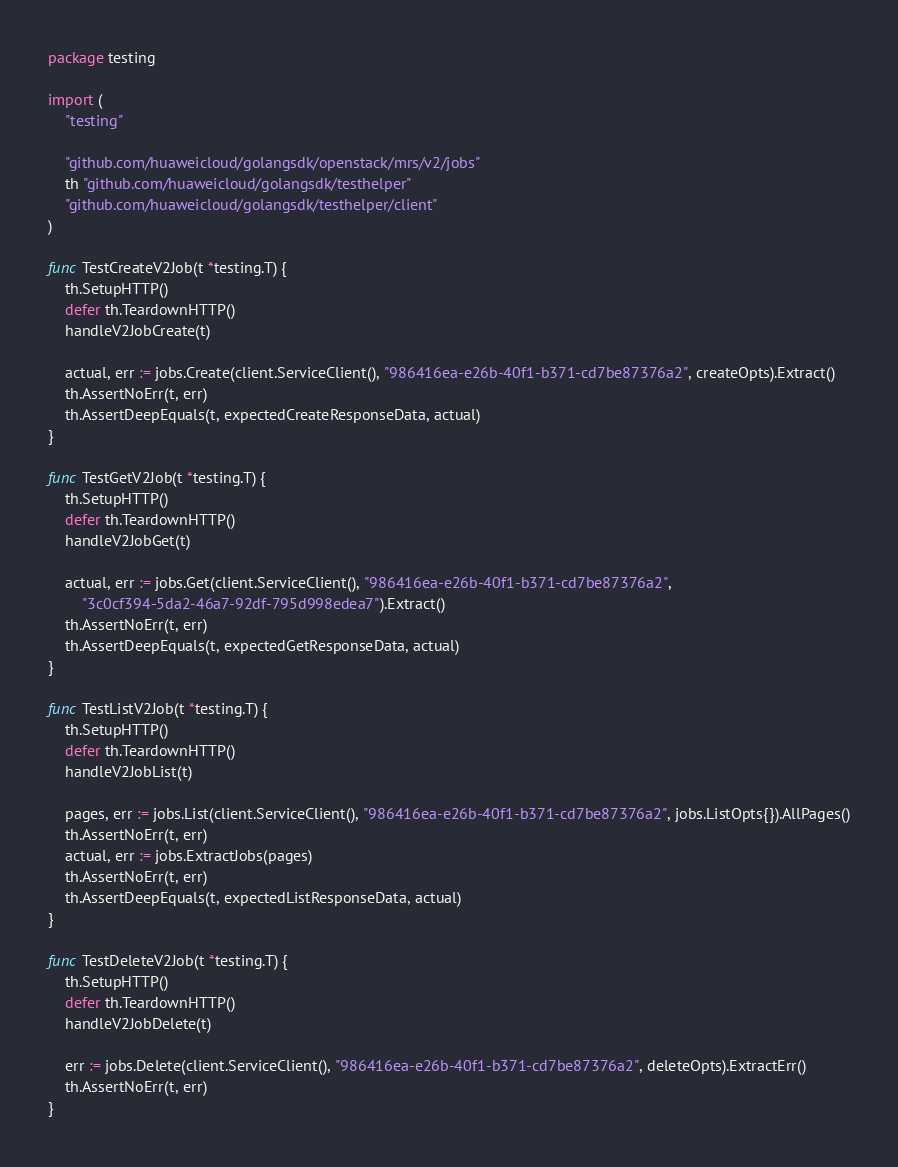Convert code to text. <code><loc_0><loc_0><loc_500><loc_500><_Go_>package testing

import (
	"testing"

	"github.com/huaweicloud/golangsdk/openstack/mrs/v2/jobs"
	th "github.com/huaweicloud/golangsdk/testhelper"
	"github.com/huaweicloud/golangsdk/testhelper/client"
)

func TestCreateV2Job(t *testing.T) {
	th.SetupHTTP()
	defer th.TeardownHTTP()
	handleV2JobCreate(t)

	actual, err := jobs.Create(client.ServiceClient(), "986416ea-e26b-40f1-b371-cd7be87376a2", createOpts).Extract()
	th.AssertNoErr(t, err)
	th.AssertDeepEquals(t, expectedCreateResponseData, actual)
}

func TestGetV2Job(t *testing.T) {
	th.SetupHTTP()
	defer th.TeardownHTTP()
	handleV2JobGet(t)

	actual, err := jobs.Get(client.ServiceClient(), "986416ea-e26b-40f1-b371-cd7be87376a2",
		"3c0cf394-5da2-46a7-92df-795d998edea7").Extract()
	th.AssertNoErr(t, err)
	th.AssertDeepEquals(t, expectedGetResponseData, actual)
}

func TestListV2Job(t *testing.T) {
	th.SetupHTTP()
	defer th.TeardownHTTP()
	handleV2JobList(t)

	pages, err := jobs.List(client.ServiceClient(), "986416ea-e26b-40f1-b371-cd7be87376a2", jobs.ListOpts{}).AllPages()
	th.AssertNoErr(t, err)
	actual, err := jobs.ExtractJobs(pages)
	th.AssertNoErr(t, err)
	th.AssertDeepEquals(t, expectedListResponseData, actual)
}

func TestDeleteV2Job(t *testing.T) {
	th.SetupHTTP()
	defer th.TeardownHTTP()
	handleV2JobDelete(t)

	err := jobs.Delete(client.ServiceClient(), "986416ea-e26b-40f1-b371-cd7be87376a2", deleteOpts).ExtractErr()
	th.AssertNoErr(t, err)
}
</code> 